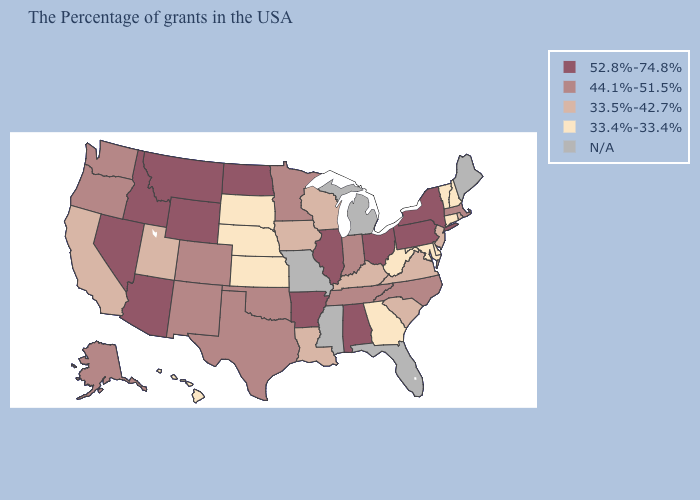What is the value of Delaware?
Concise answer only. 33.4%-33.4%. What is the value of Pennsylvania?
Concise answer only. 52.8%-74.8%. What is the value of Alabama?
Keep it brief. 52.8%-74.8%. What is the value of Washington?
Write a very short answer. 44.1%-51.5%. Does Indiana have the highest value in the MidWest?
Give a very brief answer. No. What is the value of Alaska?
Write a very short answer. 44.1%-51.5%. Name the states that have a value in the range 33.5%-42.7%?
Be succinct. Rhode Island, New Jersey, Virginia, South Carolina, Kentucky, Wisconsin, Louisiana, Iowa, Utah, California. Is the legend a continuous bar?
Answer briefly. No. What is the value of Indiana?
Quick response, please. 44.1%-51.5%. What is the value of North Carolina?
Be succinct. 44.1%-51.5%. What is the highest value in the USA?
Concise answer only. 52.8%-74.8%. Does New York have the lowest value in the USA?
Short answer required. No. What is the value of Kentucky?
Keep it brief. 33.5%-42.7%. What is the value of Alaska?
Give a very brief answer. 44.1%-51.5%. Which states hav the highest value in the Northeast?
Concise answer only. New York, Pennsylvania. 